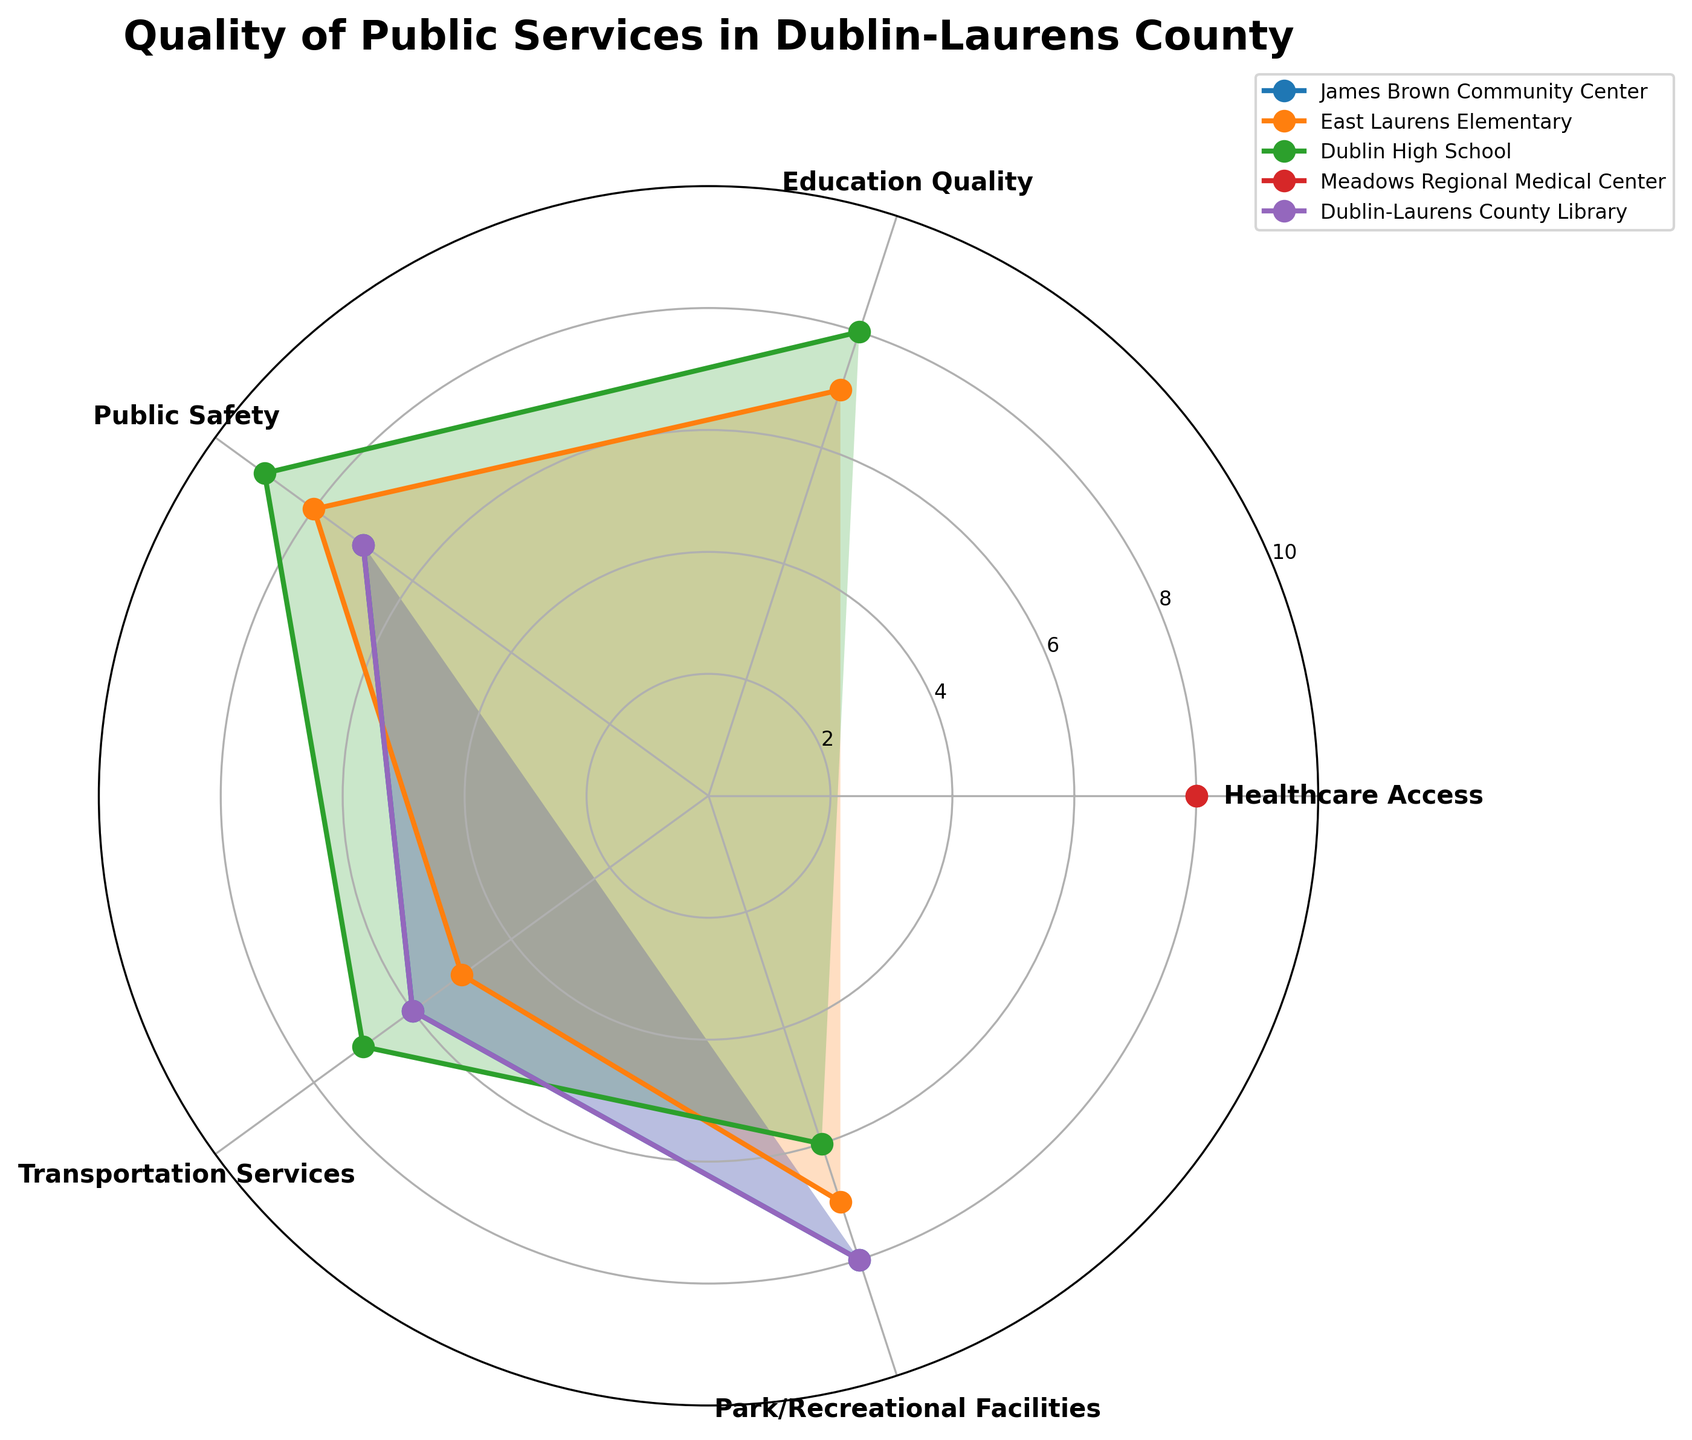How many categories are displayed in the radar chart? There are five categories shown in the radar chart, namely Healthcare Access, Education Quality, Public Safety, Transportation Services, and Park/Recreational Facilities.
Answer: Five Which location has the highest rating in Public Safety? By observing the radar chart, Dublin High School has the highest rating in Public Safety with a score of 9.
Answer: Dublin High School Which service category has the most missing data (NA)? Healthcare Access has the most missing data (NA) as it is not rated for James Brown Community Center, East Laurens Elementary, Dublin High School, and Dublin-Laurens County Library.
Answer: Healthcare Access Compare the Park/Recreational Facilities ratings for all locations. Which location has the highest and lowest ratings? In the radar chart, James Brown Community Center and Dublin-Laurens County Library both have the highest rating for Park/Recreational Facilities with a score of 8, while Dublin High School has the lowest with a rating of 6.
Answer: Highest: James Brown Community Center and Dublin-Laurens County Library, Lowest: Dublin High School What is the average rating for Transportation Services across all locations? Adding the ratings for Transportation Services: 6 (James Brown Community Center) + 5 (East Laurens Elementary) + 7 (Dublin High School) + 6 (Dublin-Laurens County Library) and dividing by the number of rated locations (4): (6+5+7+6)/4 = 6.
Answer: 6 How does the rating of Education Quality at East Laurens Elementary compare to that at Dublin High School? In the radar chart, East Laurens Elementary has an Education Quality rating of 7, while Dublin High School has a rating of 8. Therefore, Dublin High School's Education Quality rating is higher by 1 point.
Answer: Dublin High School's rating is higher by 1 point Which service category has the highest overall rating across all locations? Observing the highest ratings in each category: Healthcare Access (8), Education Quality (8), Public Safety (9), Transportation Services (7), Park/Recreational Facilities (8). Public Safety has the highest overall rating with a score of 9 at Dublin High School.
Answer: Public Safety Are there any service categories where all locations have been rated? If yes, which one(s)? From the chart, only Public Safety, Transportation Services, and Park/Recreational Facilities have ratings for all locations.
Answer: Public Safety, Transportation Services, Park/Recreational Facilities What is the difference between the highest and lowest rating in Public Safety for all locations? The highest rating in Public Safety is 9 (Dublin High School), and the lowest rating is 7 (James Brown Community Center and Dublin-Laurens County Library). The difference is 9 - 7 = 2.
Answer: 2 